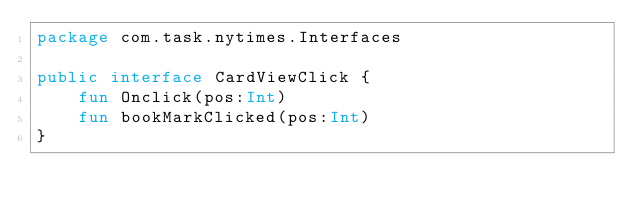<code> <loc_0><loc_0><loc_500><loc_500><_Kotlin_>package com.task.nytimes.Interfaces

public interface CardViewClick {
    fun Onclick(pos:Int)
    fun bookMarkClicked(pos:Int)
}</code> 